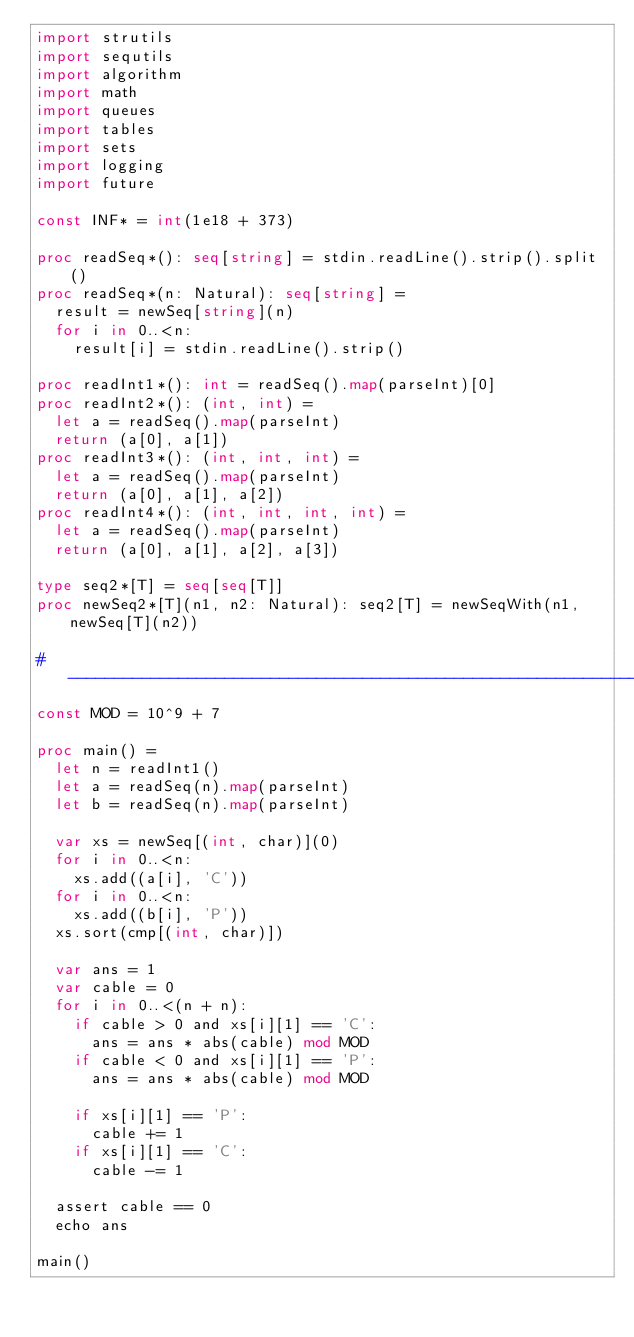Convert code to text. <code><loc_0><loc_0><loc_500><loc_500><_Nim_>import strutils
import sequtils
import algorithm
import math
import queues
import tables
import sets
import logging
import future

const INF* = int(1e18 + 373)

proc readSeq*(): seq[string] = stdin.readLine().strip().split()
proc readSeq*(n: Natural): seq[string] =
  result = newSeq[string](n)
  for i in 0..<n:
    result[i] = stdin.readLine().strip()

proc readInt1*(): int = readSeq().map(parseInt)[0]
proc readInt2*(): (int, int) =
  let a = readSeq().map(parseInt)
  return (a[0], a[1])
proc readInt3*(): (int, int, int) =
  let a = readSeq().map(parseInt)
  return (a[0], a[1], a[2])
proc readInt4*(): (int, int, int, int) =
  let a = readSeq().map(parseInt)
  return (a[0], a[1], a[2], a[3])

type seq2*[T] = seq[seq[T]]
proc newSeq2*[T](n1, n2: Natural): seq2[T] = newSeqWith(n1, newSeq[T](n2))

#------------------------------------------------------------------------------#
const MOD = 10^9 + 7

proc main() =
  let n = readInt1()
  let a = readSeq(n).map(parseInt)
  let b = readSeq(n).map(parseInt)

  var xs = newSeq[(int, char)](0)
  for i in 0..<n:
    xs.add((a[i], 'C'))
  for i in 0..<n:
    xs.add((b[i], 'P'))
  xs.sort(cmp[(int, char)])

  var ans = 1
  var cable = 0
  for i in 0..<(n + n):
    if cable > 0 and xs[i][1] == 'C':
      ans = ans * abs(cable) mod MOD
    if cable < 0 and xs[i][1] == 'P':
      ans = ans * abs(cable) mod MOD

    if xs[i][1] == 'P':
      cable += 1
    if xs[i][1] == 'C':
      cable -= 1

  assert cable == 0
  echo ans

main()

</code> 